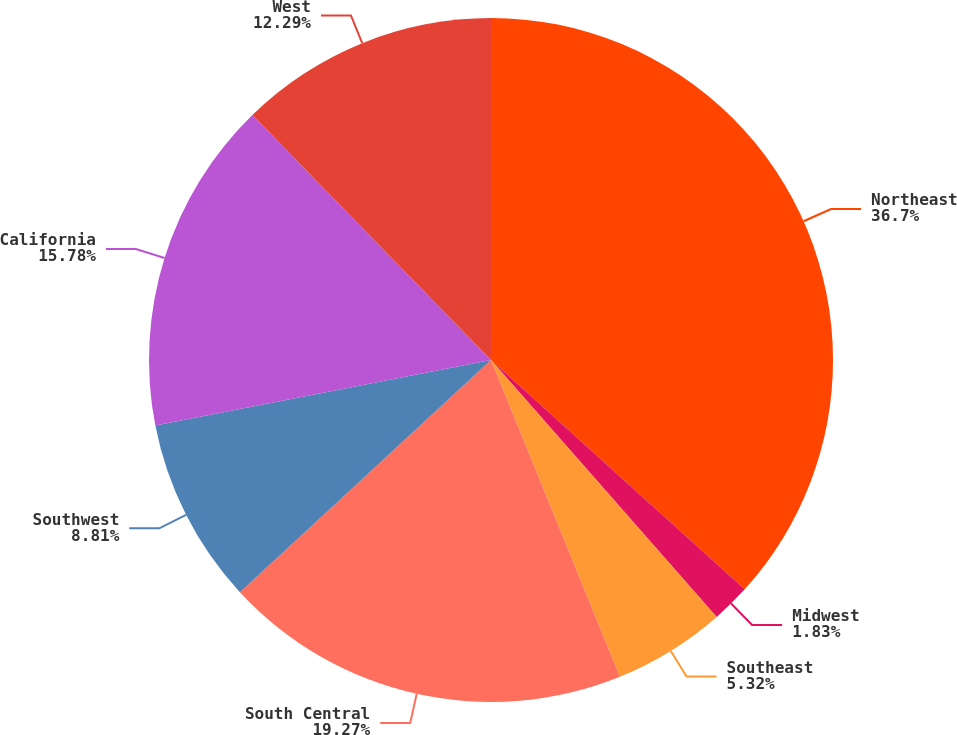Convert chart to OTSL. <chart><loc_0><loc_0><loc_500><loc_500><pie_chart><fcel>Northeast<fcel>Midwest<fcel>Southeast<fcel>South Central<fcel>Southwest<fcel>California<fcel>West<nl><fcel>36.7%<fcel>1.83%<fcel>5.32%<fcel>19.27%<fcel>8.81%<fcel>15.78%<fcel>12.29%<nl></chart> 